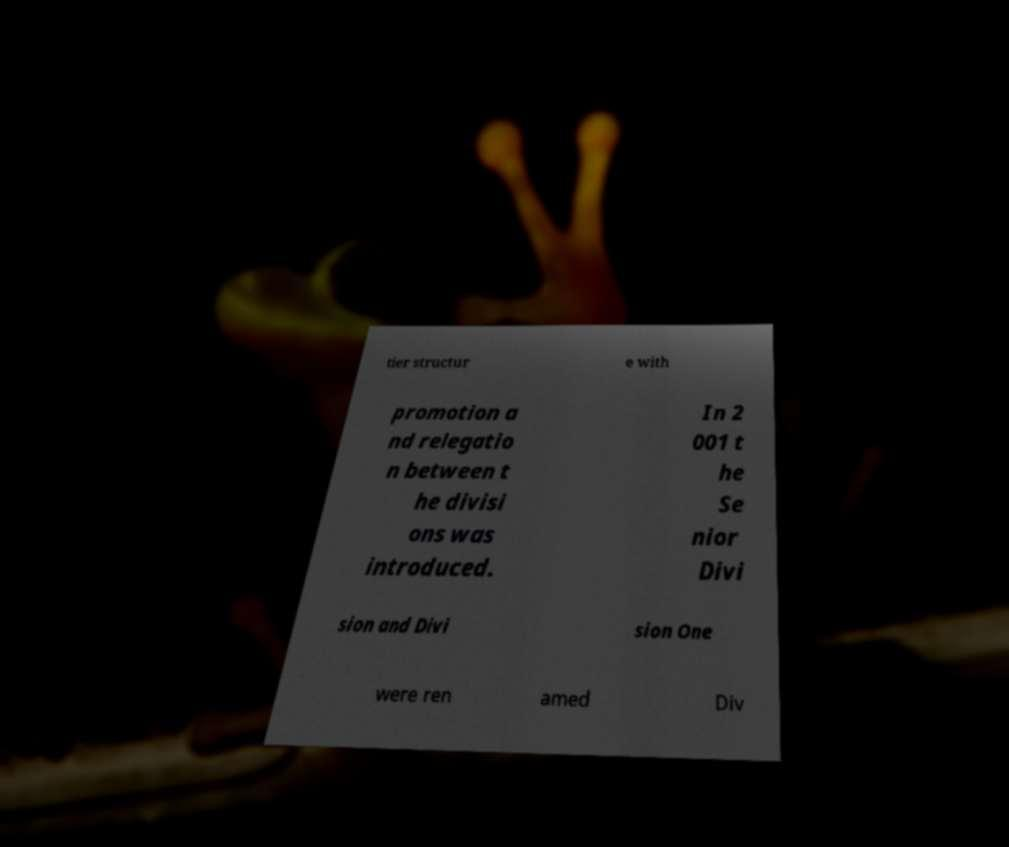Could you extract and type out the text from this image? tier structur e with promotion a nd relegatio n between t he divisi ons was introduced. In 2 001 t he Se nior Divi sion and Divi sion One were ren amed Div 